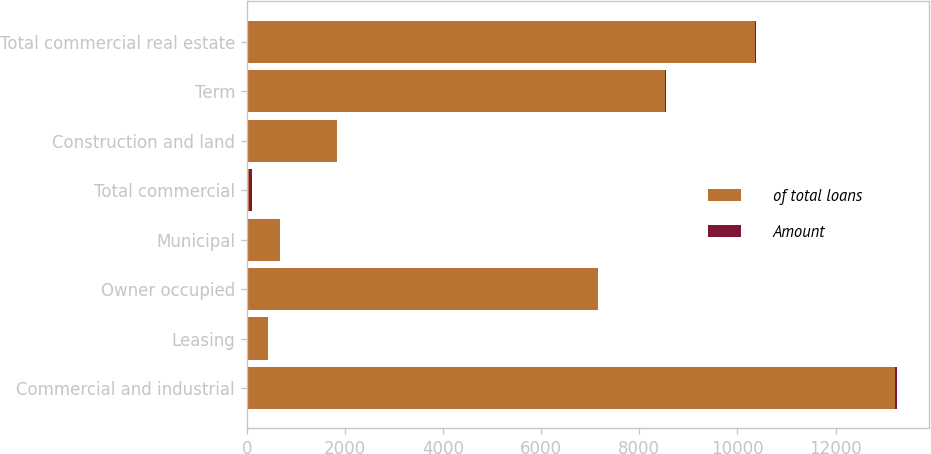Convert chart to OTSL. <chart><loc_0><loc_0><loc_500><loc_500><stacked_bar_chart><ecel><fcel>Commercial and industrial<fcel>Leasing<fcel>Owner occupied<fcel>Municipal<fcel>Total commercial<fcel>Construction and land<fcel>Term<fcel>Total commercial real estate<nl><fcel>of total loans<fcel>13211<fcel>442<fcel>7150<fcel>676<fcel>52.9<fcel>1842<fcel>8514<fcel>10356<nl><fcel>Amount<fcel>32.5<fcel>1.1<fcel>17.6<fcel>1.7<fcel>52.9<fcel>4.5<fcel>21<fcel>25.5<nl></chart> 